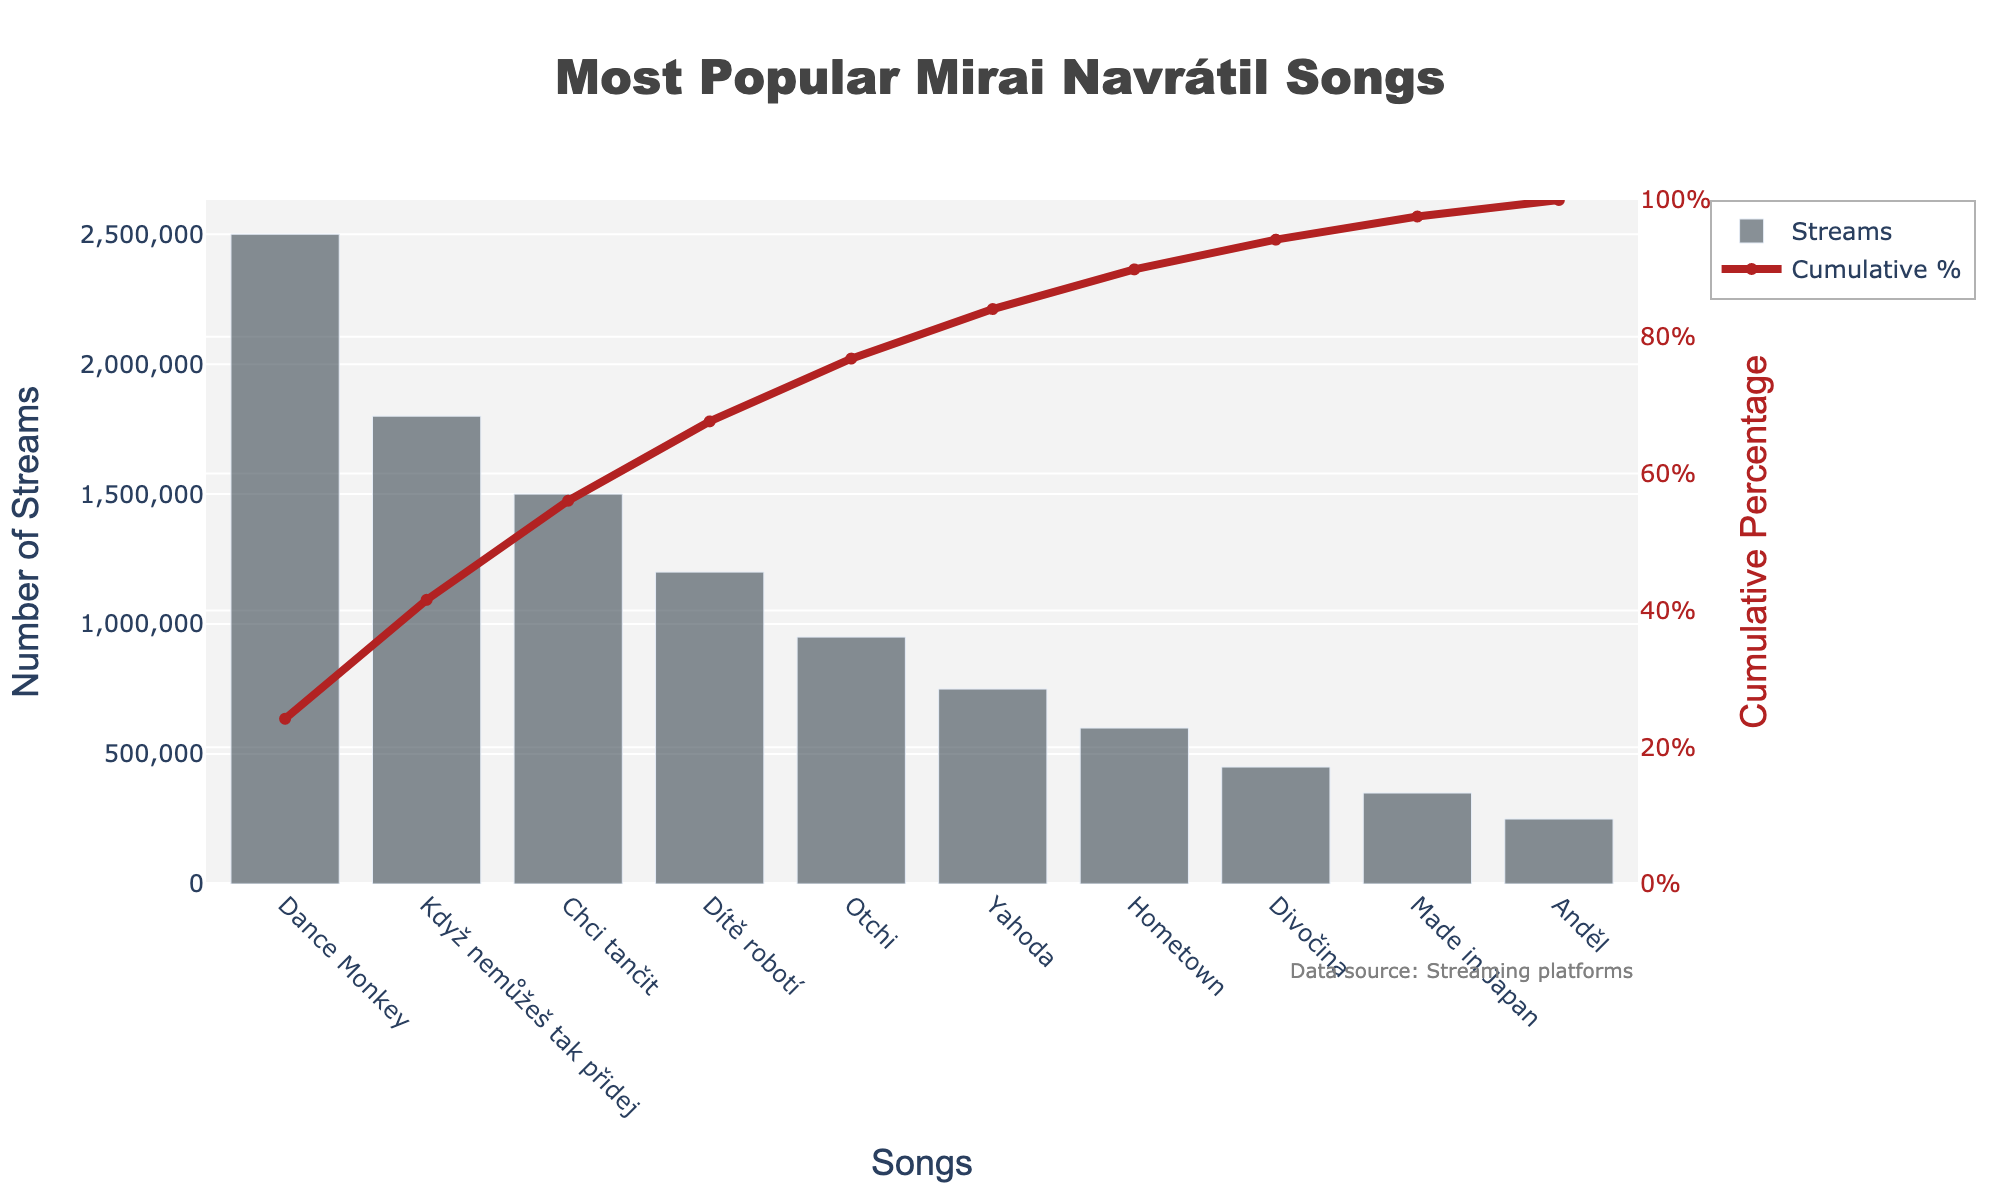What is the title of the chart? The title is located at the top of the chart and is prominently displayed.
Answer: Most Popular Mirai Navrátil Songs Which song has the highest number of streams? The bar representing the song with the highest number of streams is the tallest in the chart.
Answer: Dance Monkey What is the cumulative percentage for the song "Chci tančit"? The line on the chart represents the cumulative percentage. Find the point where "Chci tančit" is plotted and read off the corresponding cumulative percentage value.
Answer: 69.1% How many songs have a cumulative percentage below 50%? Locate the cumulative percentage line and find the point where it crosses 50%. Count the number of songs before this point.
Answer: 2 What is the total amount of streams for the first three songs? Sum the number of streams for the first three songs: Dance Monkey (2,500,000), Když nemůžeš tak přidej (1,800,000), and Chci tančit (1,500,000).
Answer: 5,800,000 Is the cumulative percentage more than 75% after the top six songs? Look at the cumulative percentage line after the sixth song and see if it's above 75%.
Answer: No How many streams does the song "Otchi" have? Find the bar corresponding to the song "Otchi" and read off the number of streams from the y-axis.
Answer: 950,000 What is the difference in streams between "Hometown" and "Divočina"? Subtract the number of streams for "Divočina" (450,000) from "Hometown" (600,000).
Answer: 150,000 Which songs contribute to reaching just above 90% cumulative percentage? Follow the cumulative percentage line until it passes 90%, then list the corresponding songs.
Answer: Dance Monkey, Když nemůžeš tak přidej, Chci tančit, Dítě robotí, Otchi, Yahoda What is the average number of streams for all songs except "Dance Monkey"? Sum the streams of all songs except "Dance Monkey" and divide by the number of those songs (9). Total streams for the other songs: 6,200,000. Calculate 6,200,000 / 9.
Answer: 688,889 